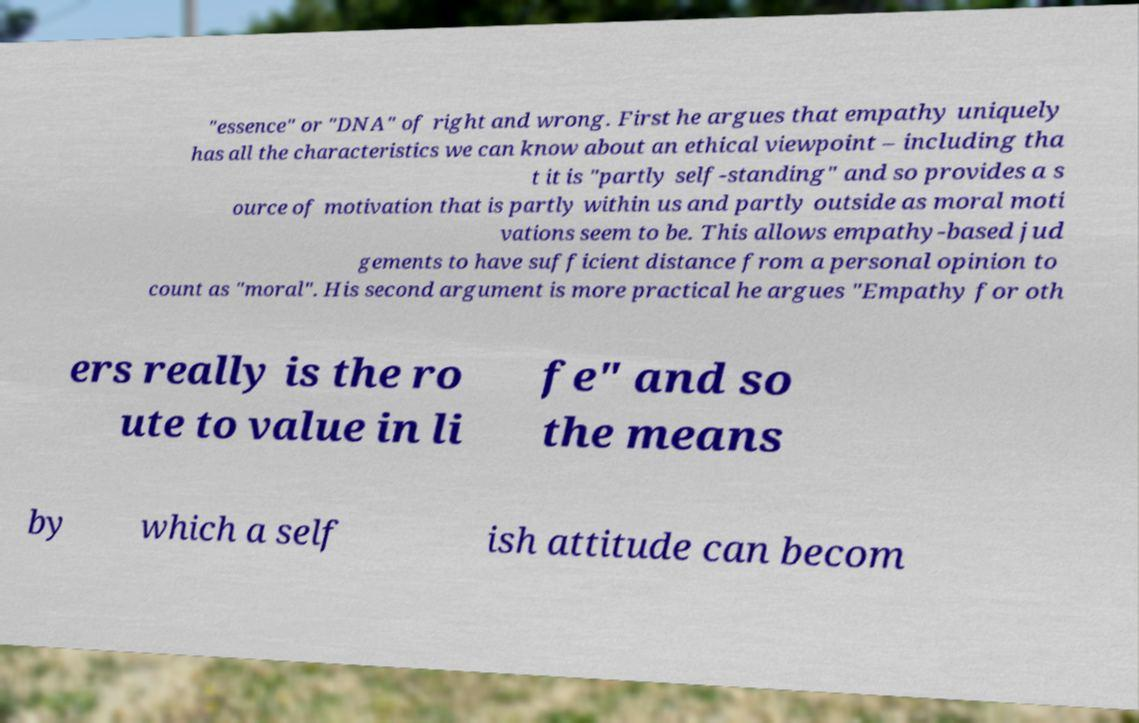There's text embedded in this image that I need extracted. Can you transcribe it verbatim? "essence" or "DNA" of right and wrong. First he argues that empathy uniquely has all the characteristics we can know about an ethical viewpoint – including tha t it is "partly self-standing" and so provides a s ource of motivation that is partly within us and partly outside as moral moti vations seem to be. This allows empathy-based jud gements to have sufficient distance from a personal opinion to count as "moral". His second argument is more practical he argues "Empathy for oth ers really is the ro ute to value in li fe" and so the means by which a self ish attitude can becom 